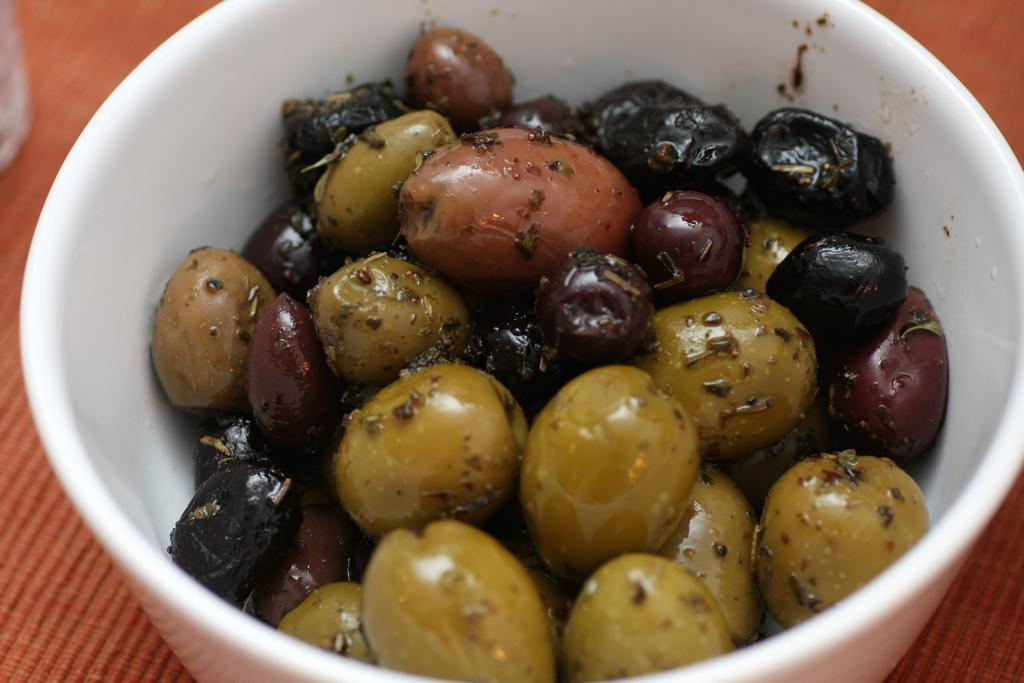What is in the image that can hold food or liquid? There is a bowl in the image. What color is the bowl? The bowl is white in color. What colors can be seen in the food inside the bowl? The food in the bowl has black, maroon, and green colors. What is the color of the surface the bowl is placed on? The food is on a brown surface. Can you tell me how many mint leaves are in the bowl? There is no mention of mint leaves in the image, so it is not possible to determine their number. 